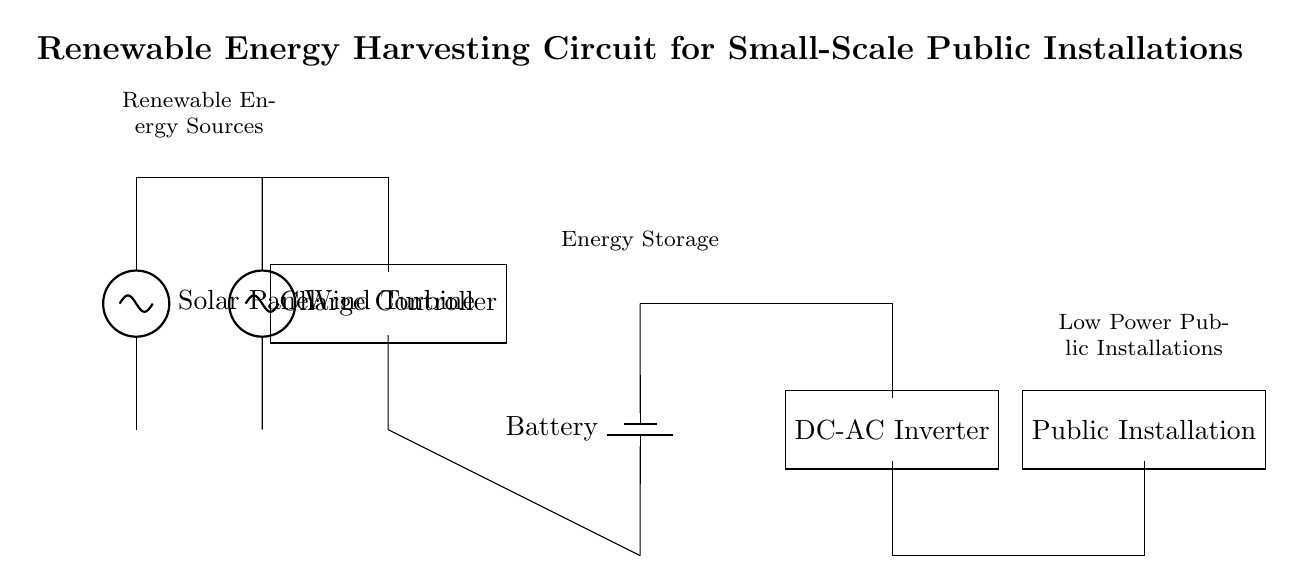What types of renewable energy sources are used in this circuit? The circuit utilizes a solar panel and a wind turbine as renewable energy sources, which can be identified from the labels in the diagram.
Answer: Solar panel, wind turbine What component is responsible for regulating the charge going into the battery? The charge controller is the component that manages the power received from the renewable sources before it is stored in the battery. This can be seen as connected between the energy sources and the battery in the diagram.
Answer: Charge controller What is the purpose of the DC-AC inverter in this circuit? The DC-AC inverter converts the stored direct current from the battery into alternating current, suitable for powering standard public appliances. This can be inferred from its position in the circuit diagram following the battery.
Answer: Convert DC to AC How many total energy sources are present in the circuit? There are two energy sources depicted in the circuit: the solar panel and the wind turbine. Each energy source can be counted to arrive at the total.
Answer: Two What is the output load type connected to the DC-AC inverter? The load is labeled as "Public Installation", which indicates that it is designed to power a public installation, such as streetlights or small community systems. This is identified clearly in the diagram as the component following the inverter.
Answer: Public installation Explain how energy flows from the renewable sources to the public installation. Energy first flows from the solar panel and wind turbine to the charge controller, which regulates it. Then it goes into the battery for storage. When the public installation requires power, the stored energy is fed through the DC-AC inverter, converting it for use in alternating current format. This path can be traced through the connections shown in the circuit.
Answer: Renewable sources → Charge controller → Battery → DC-AC inverter → Public installation What type of appliances is this circuit designed to power? The circuit is designed to power low power public installations, as indicated by the label on the load component in the diagram which specifically mentions "Public Installation".
Answer: Low power public installations 